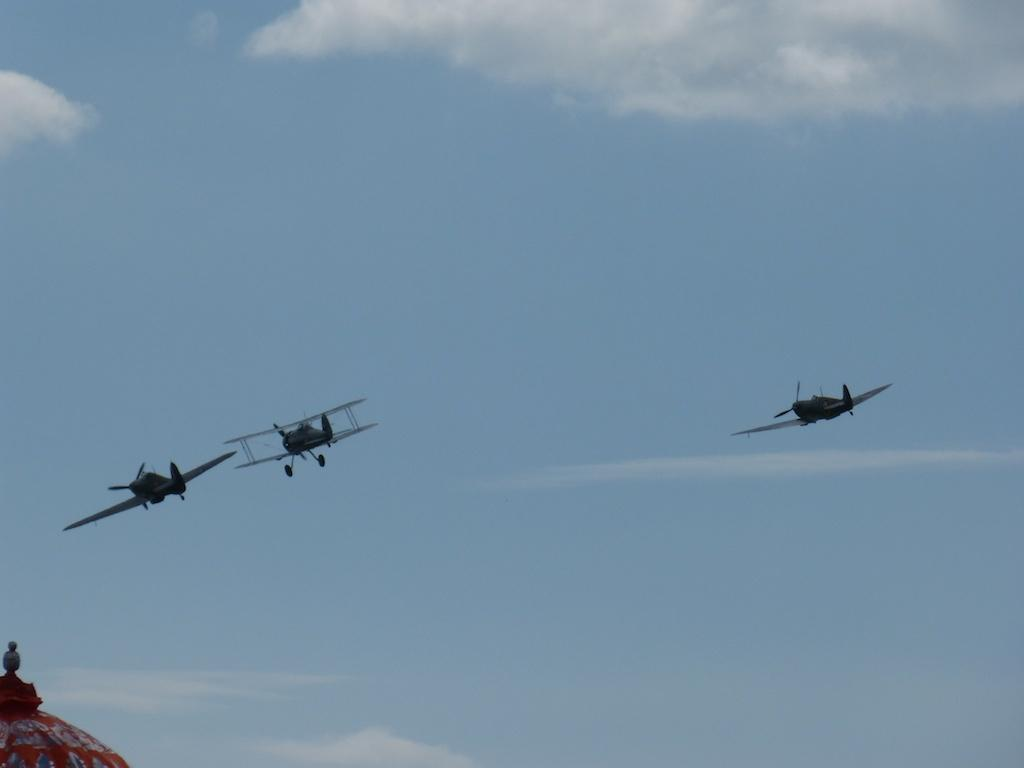What can be seen in the sky in the image? There are airplanes in the sky in the image. What is visible at the bottom of the image? There is a tip of a building at the bottom of the image. What type of muscle is being exercised by the airplanes in the image? There are no muscles present in the image, as it features airplanes in the sky and a building tip. What reason might the airplanes have for being in the sky in the image? The image does not provide any information about the reason for the airplanes being in the sky, so it cannot be determined from the image. 